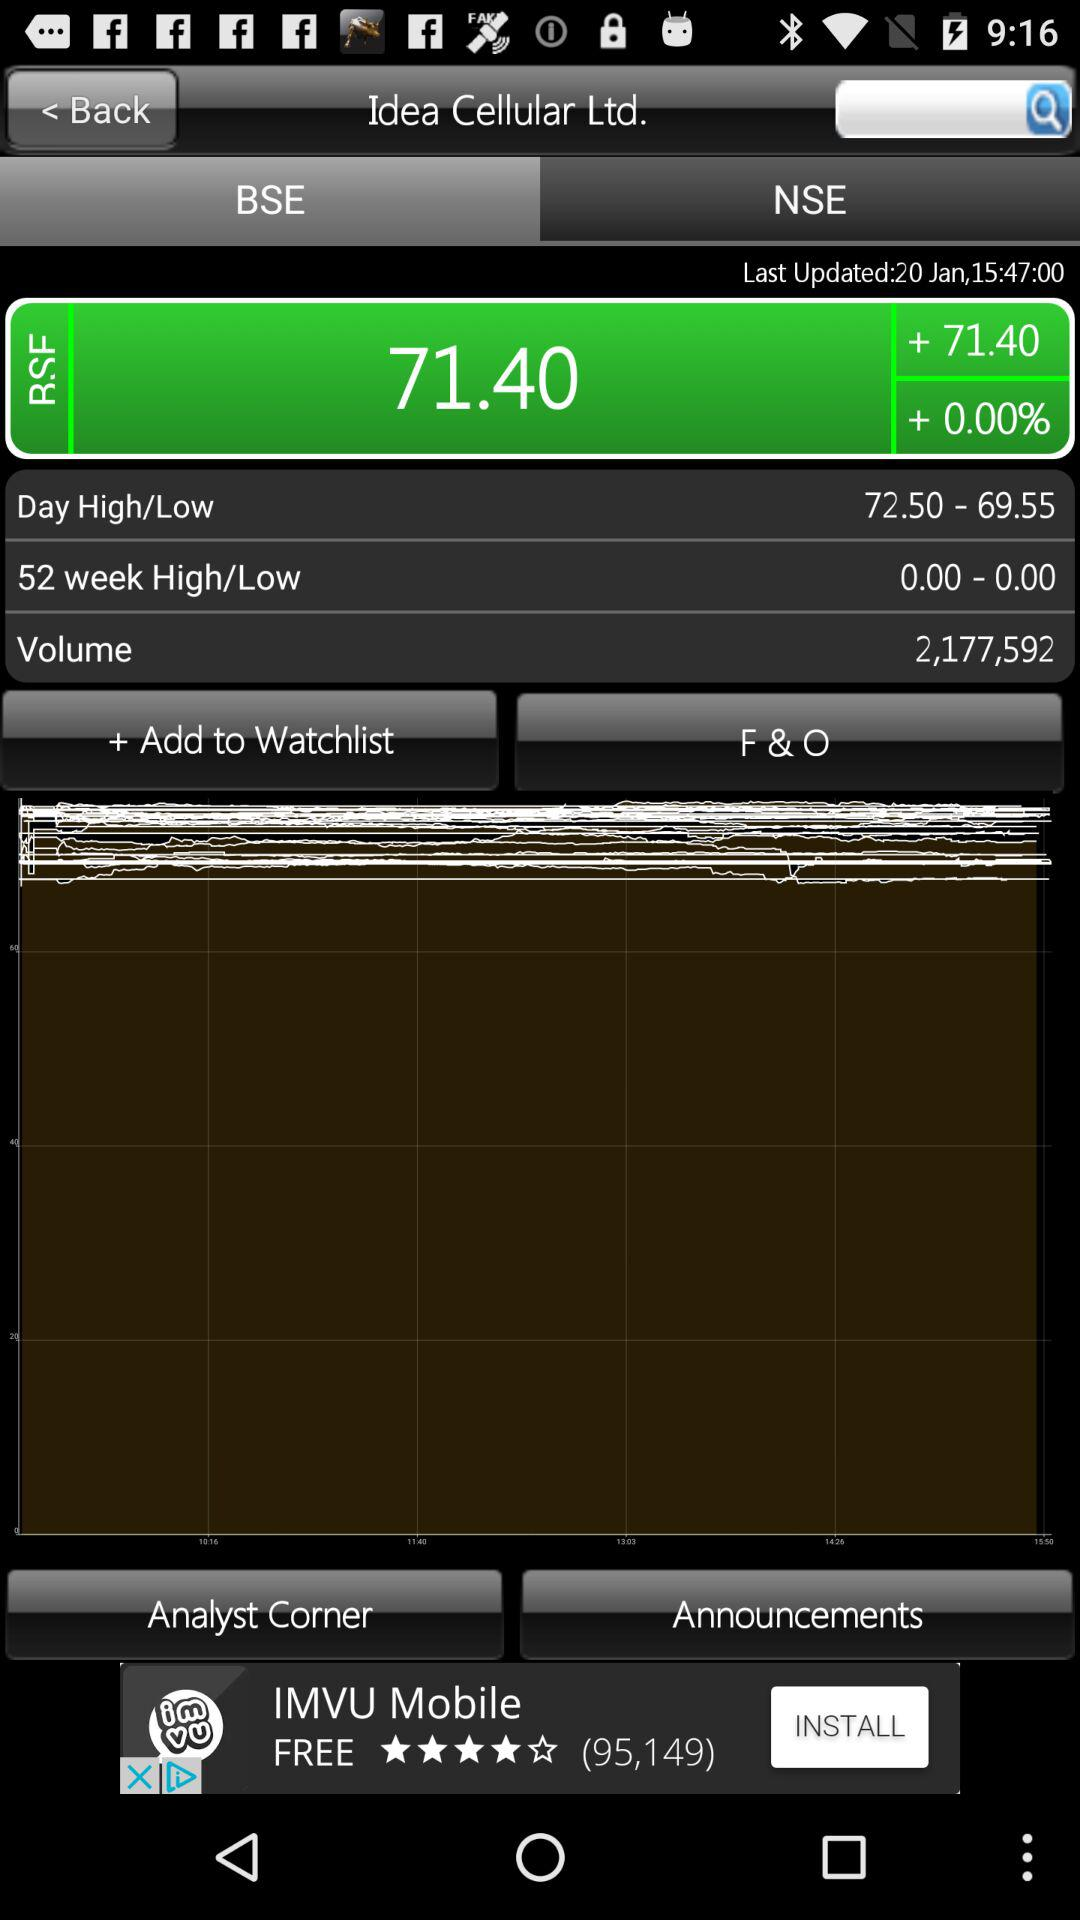What is the total volume of shares traded?
Answer the question using a single word or phrase. 2,177,592 